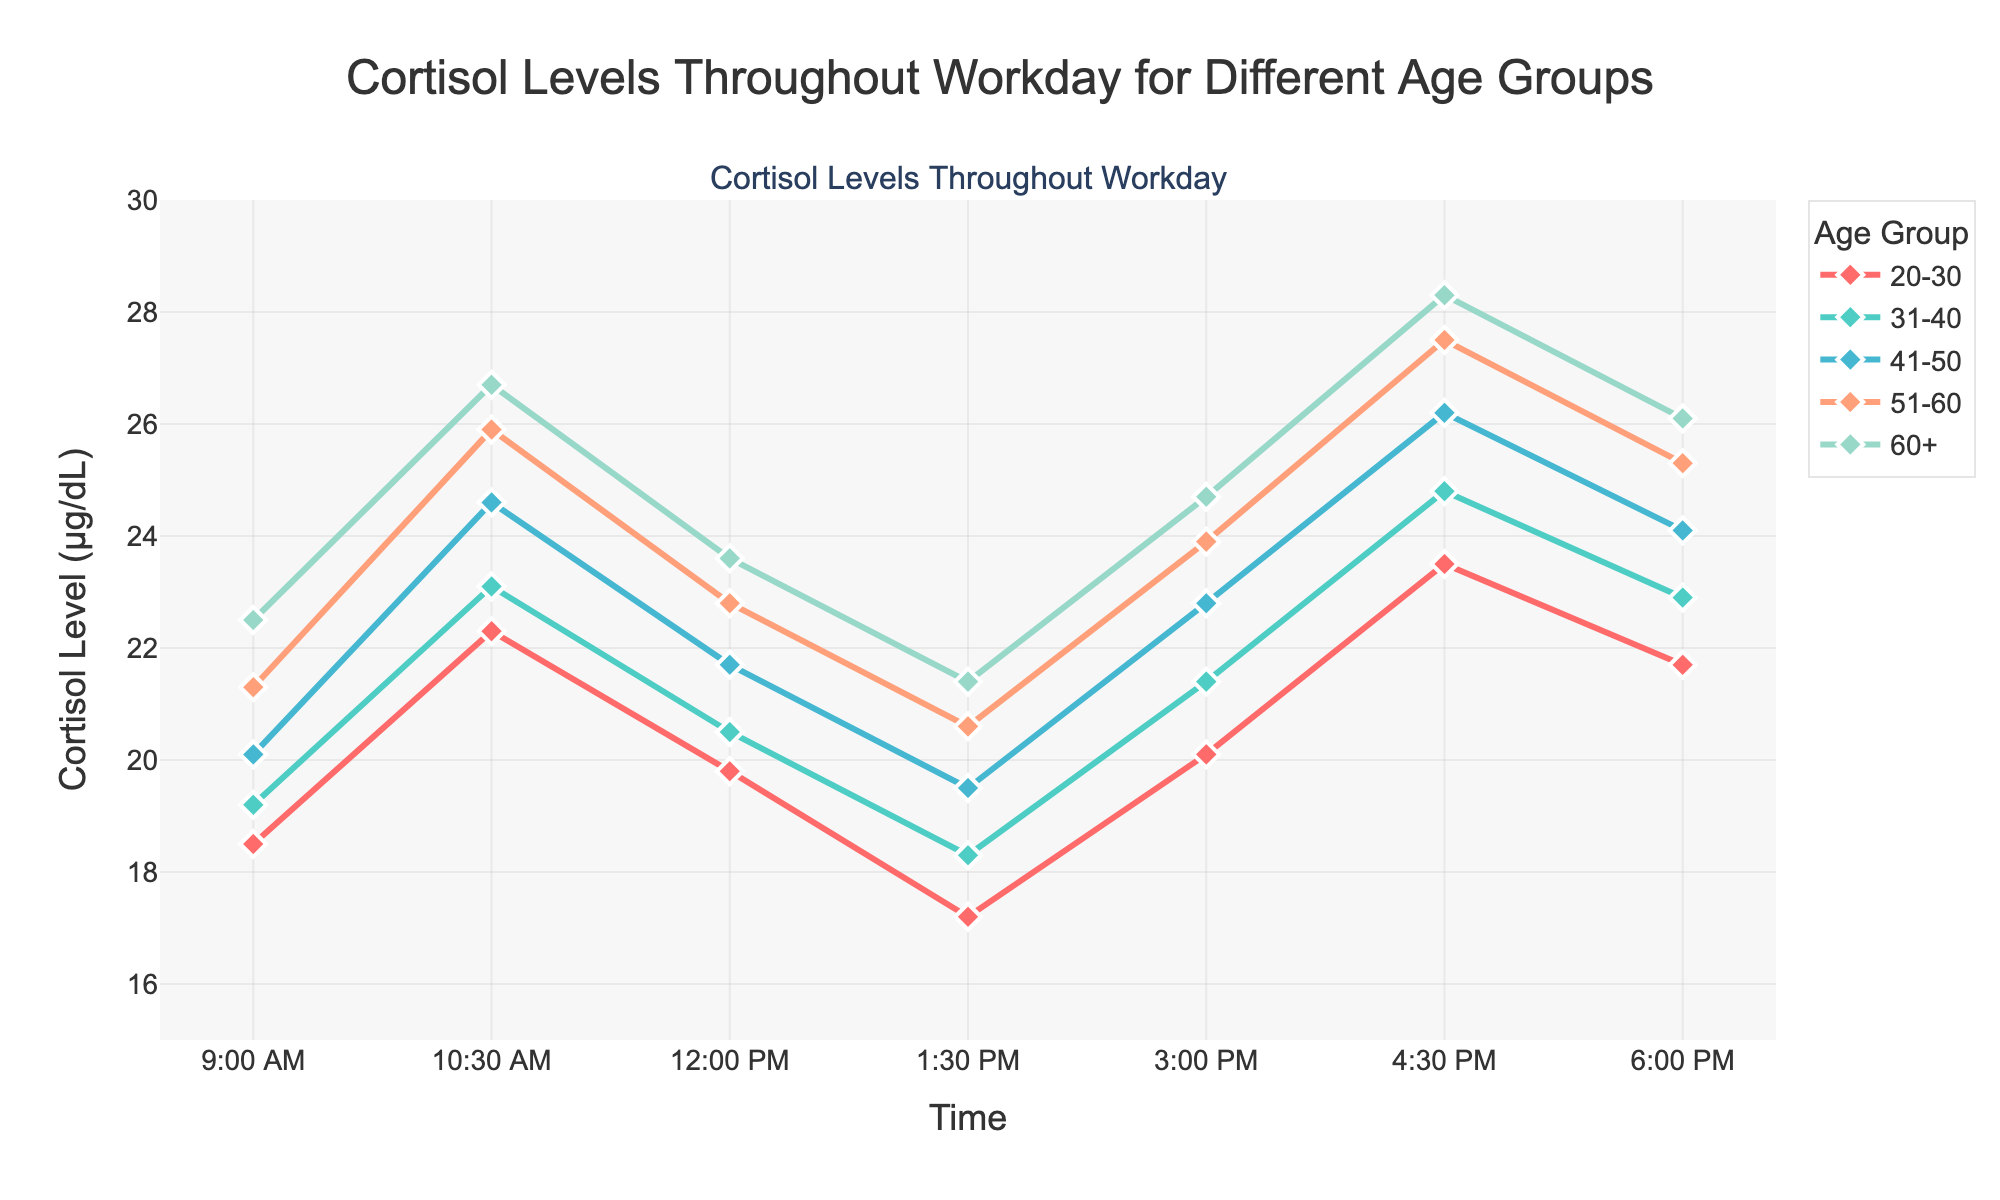What's the highest cortisol level for the 31-40 age group, and at what time does it occur? To find the highest cortisol level for the 31-40 age group, look at the plotted values for this group and identify the maximum value. The maximum value for the 31-40 age group is 24.8 μg/dL, which occurs at 4:30 PM.
Answer: 24.8 μg/dL at 4:30 PM Among all age groups, which one has the lowest cortisol level at 9:00 AM? To determine the lowest cortisol level at 9:00 AM across all age groups, compare the cortisol levels for each group at this time point. The 20-30 age group has the lowest cortisol level at 9:00 AM with a value of 18.5 μg/dL.
Answer: 20-30 age group Between 10:30 AM and 12:00 PM, which age group shows the most significant decrease in cortisol level? Calculate the difference in cortisol levels between 10:30 AM and 12:00 PM for each age group. The 51-60 age group shows the most significant decrease, with a difference of 25.9 - 22.8 = 3.1 μg/dL.
Answer: 51-60 age group What's the average cortisol level at 3:00 PM across all age groups? To find the average cortisol level at 3:00 PM, sum the cortisol levels at this time for all age groups and divide by the number of groups. \( (20.1 + 21.4 + 22.8 + 23.9 + 24.7) / 5 = 22.58 \) μg/dL.
Answer: 22.58 μg/dL Compare the trend between the 41-50 and 60+ age groups; which group has a more pronounced increase in cortisol levels from 1:30 PM to 4:30 PM? Determine the differences in cortisol levels from 1:30 PM to 4:30 PM for the two groups. For the 41-50 age group: 26.2 - 19.5 = 6.7 μg/dL. For the 60+ age group: 28.3 - 21.4 = 6.9 μg/dL. The 60+ age group has a more pronounced increase.
Answer: 60+ age group Do any age groups have a continuous increase in cortisol levels between two consecutive time points? If so, which ones and at what times? Look for consecutive increases in cortisol levels for each age group between specific time points. The 20-30 age group has continuous increases from 3:00 PM (20.1) to 4:30 PM (23.5), and the 60+ age group from 1:30 PM (21.4) to 3:00 PM (24.7).
Answer: 20-30 age group (3:00 PM - 4:30 PM), 60+ age group (1:30 PM - 3:00 PM) Which age group experiences the highest overall cortisol level at any point in the day, and what is that level? Find the maximum cortisol level for each age group and compare them. The highest overall cortisol level is for the 60+ age group at 4:30 PM, with a value of 28.3 μg/dL.
Answer: 60+ age group, 28.3 μg/dL 